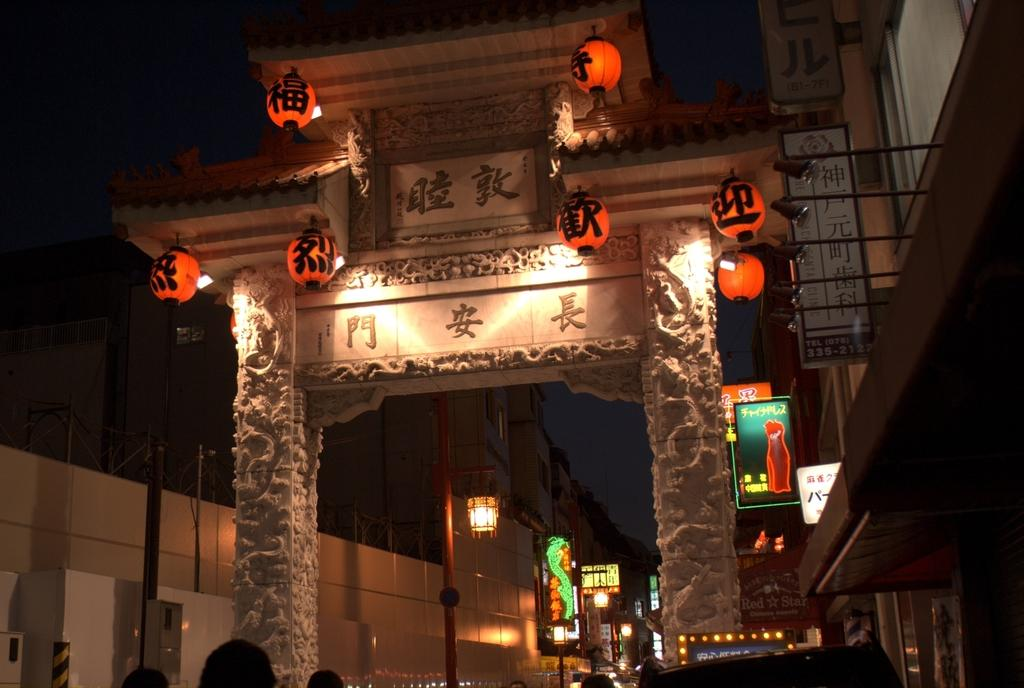What type of architectural feature is present in the image? There is an arch architecture in the image. What can be seen on the right side of the image? There are buildings on the right side of the image. What can be seen on the left side of the image? There are buildings on the left side of the image. What type of signage is present in the image? There are hoardings in the image. What can be seen illuminated in the image? There are lights visible in the image. What type of meal is being prepared in the image? There is no meal being prepared in the image; it features an arch and surrounding buildings. What type of competition is taking place in the image? There is no competition present in the image; it features an arch and surrounding buildings. 